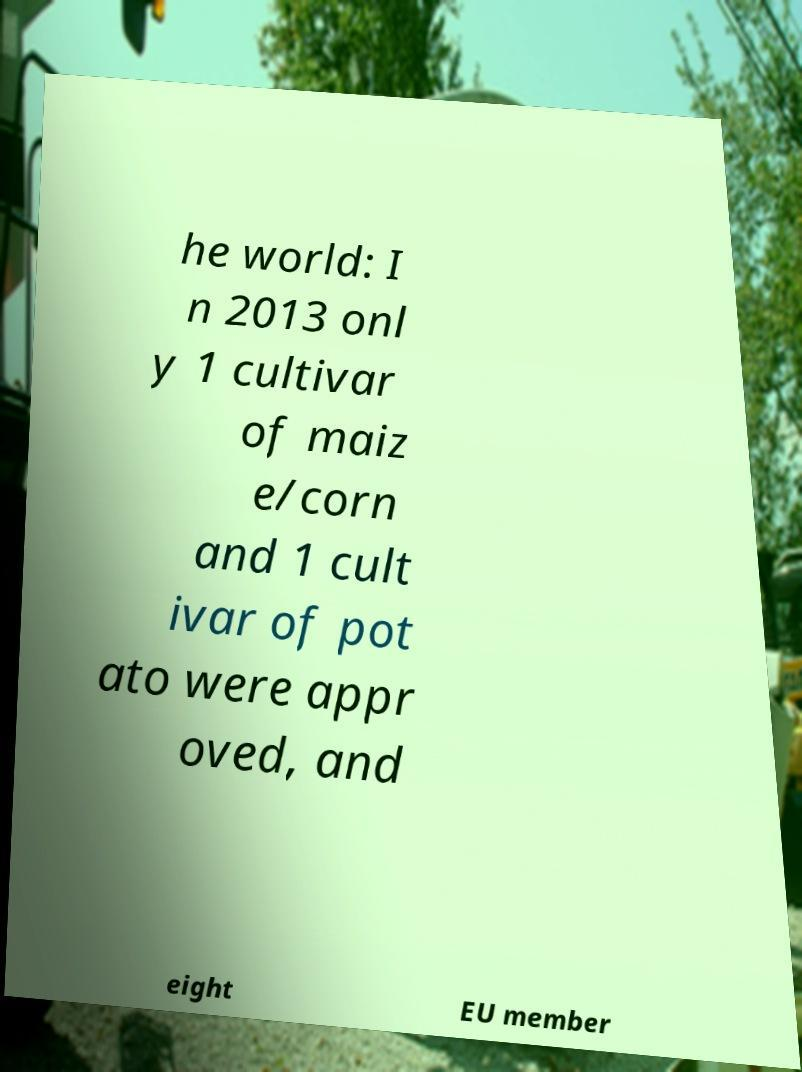What messages or text are displayed in this image? I need them in a readable, typed format. he world: I n 2013 onl y 1 cultivar of maiz e/corn and 1 cult ivar of pot ato were appr oved, and eight EU member 